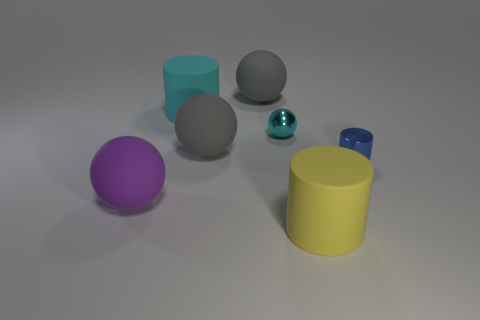What color is the large cylinder in front of the large purple sphere?
Your answer should be compact. Yellow. What size is the blue cylinder that is made of the same material as the tiny cyan ball?
Your response must be concise. Small. There is a yellow rubber cylinder; is its size the same as the gray matte sphere that is behind the small cyan object?
Give a very brief answer. Yes. What is the material of the cylinder left of the tiny cyan metal sphere?
Provide a short and direct response. Rubber. There is a large matte cylinder that is in front of the tiny blue shiny cylinder; what number of big things are in front of it?
Your response must be concise. 0. Are there any other things that have the same shape as the large yellow rubber thing?
Provide a succinct answer. Yes. There is a object that is to the right of the yellow rubber object; does it have the same size as the cylinder that is behind the metal ball?
Offer a very short reply. No. The blue metallic thing on the right side of the matte cylinder that is left of the tiny ball is what shape?
Give a very brief answer. Cylinder. How many other blue cylinders are the same size as the blue cylinder?
Your answer should be very brief. 0. Is there a tiny brown cylinder?
Your response must be concise. No. 